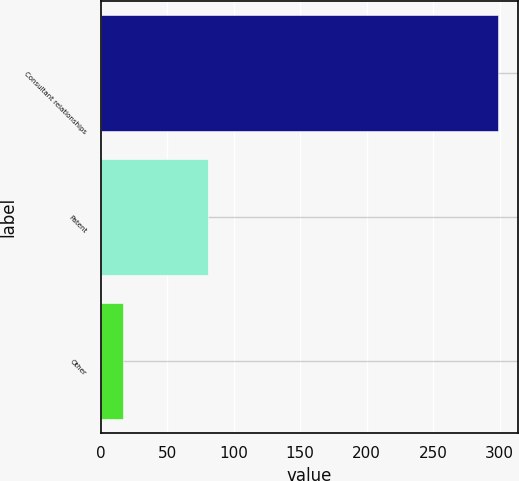Convert chart to OTSL. <chart><loc_0><loc_0><loc_500><loc_500><bar_chart><fcel>Consultant relationships<fcel>Patent<fcel>Other<nl><fcel>299<fcel>81<fcel>17<nl></chart> 